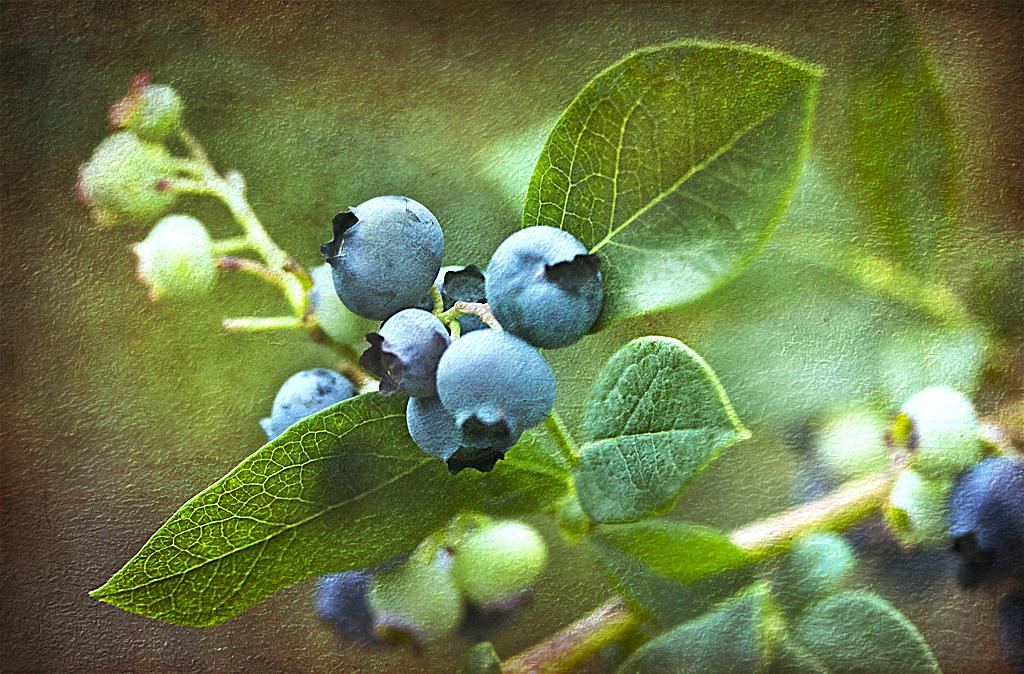What type of plant parts can be seen in the image? There are buds, leaves, and stems in the image. Can you describe the plant parts in more detail? The buds are small and may be in the process of blooming, the leaves are green and appear to be attached to the stems, and the stems are thin and support the leaves and buds. What is not clear in the image? The background of the image is not clear. Where is the harbor located in the image? There is no harbor present in the image; it features plant parts such as buds, leaves, and stems. What type of cord is used to connect the map to the wall in the image? There is no cord or map present in the image; it only contains plant parts. 